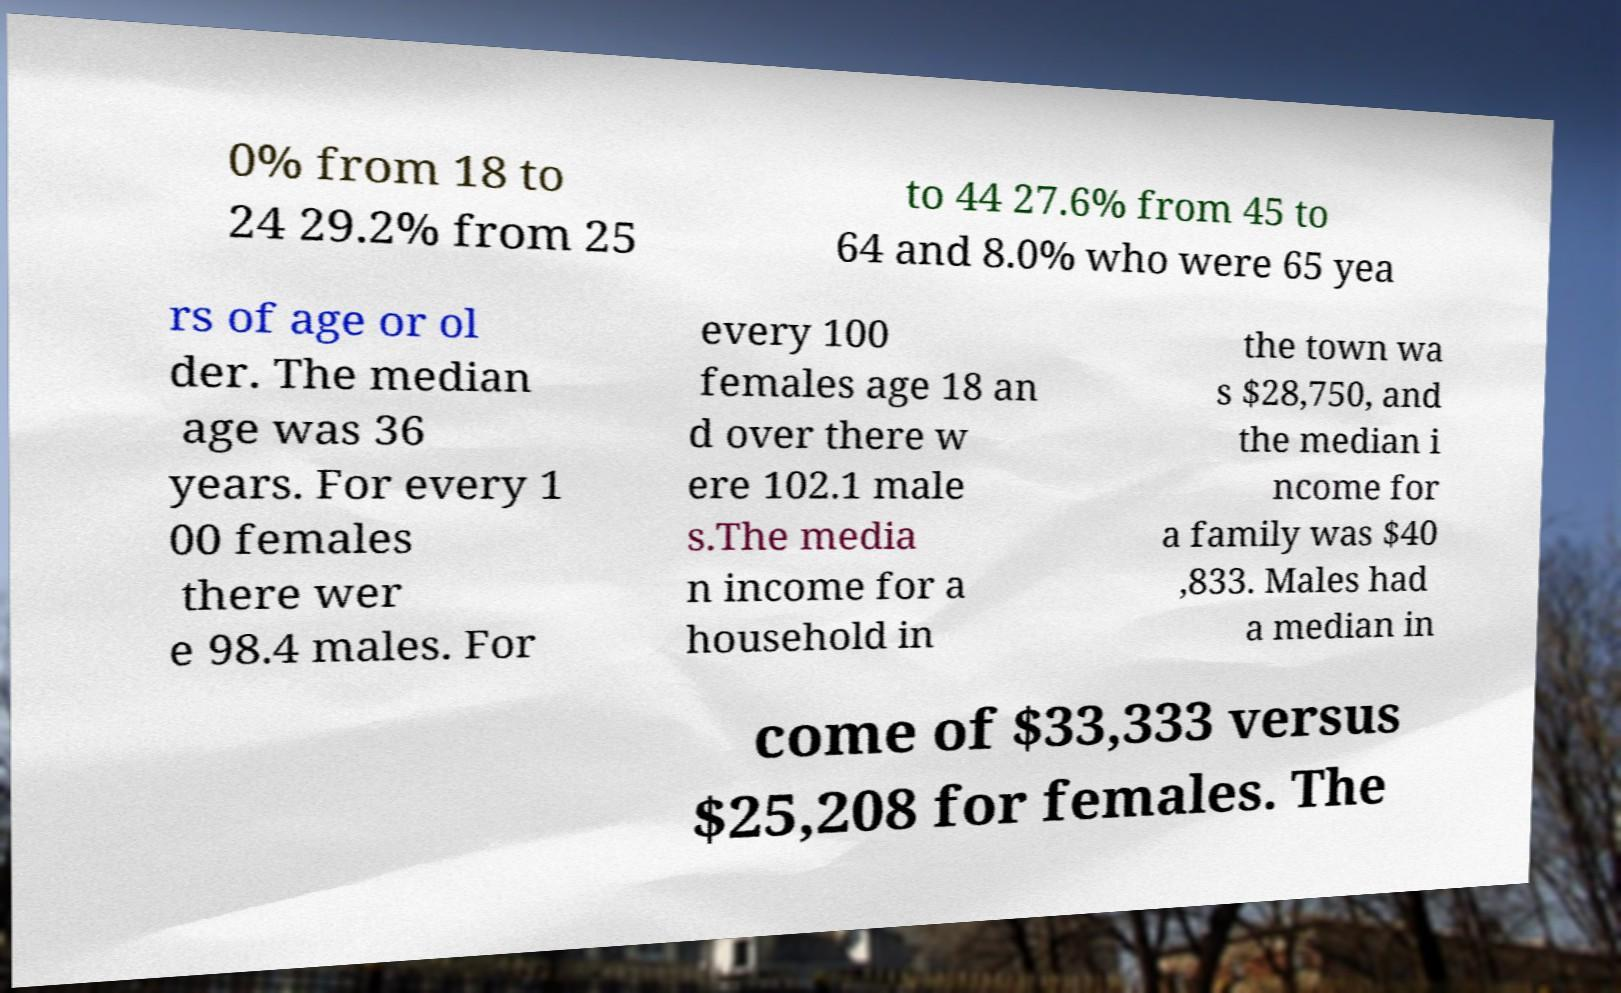Can you read and provide the text displayed in the image?This photo seems to have some interesting text. Can you extract and type it out for me? 0% from 18 to 24 29.2% from 25 to 44 27.6% from 45 to 64 and 8.0% who were 65 yea rs of age or ol der. The median age was 36 years. For every 1 00 females there wer e 98.4 males. For every 100 females age 18 an d over there w ere 102.1 male s.The media n income for a household in the town wa s $28,750, and the median i ncome for a family was $40 ,833. Males had a median in come of $33,333 versus $25,208 for females. The 